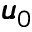Convert formula to latex. <formula><loc_0><loc_0><loc_500><loc_500>\pm b { u } _ { 0 }</formula> 